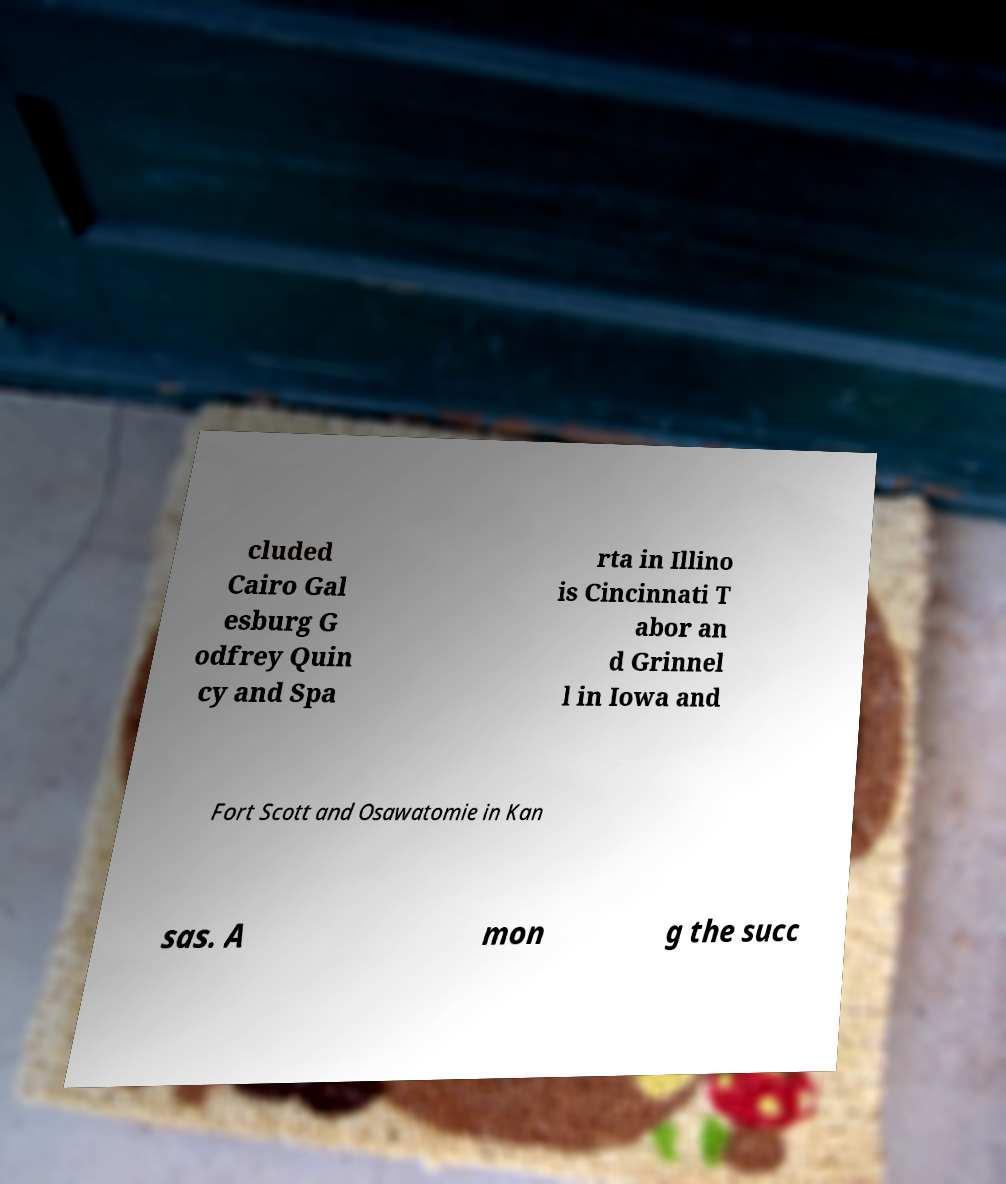I need the written content from this picture converted into text. Can you do that? cluded Cairo Gal esburg G odfrey Quin cy and Spa rta in Illino is Cincinnati T abor an d Grinnel l in Iowa and Fort Scott and Osawatomie in Kan sas. A mon g the succ 